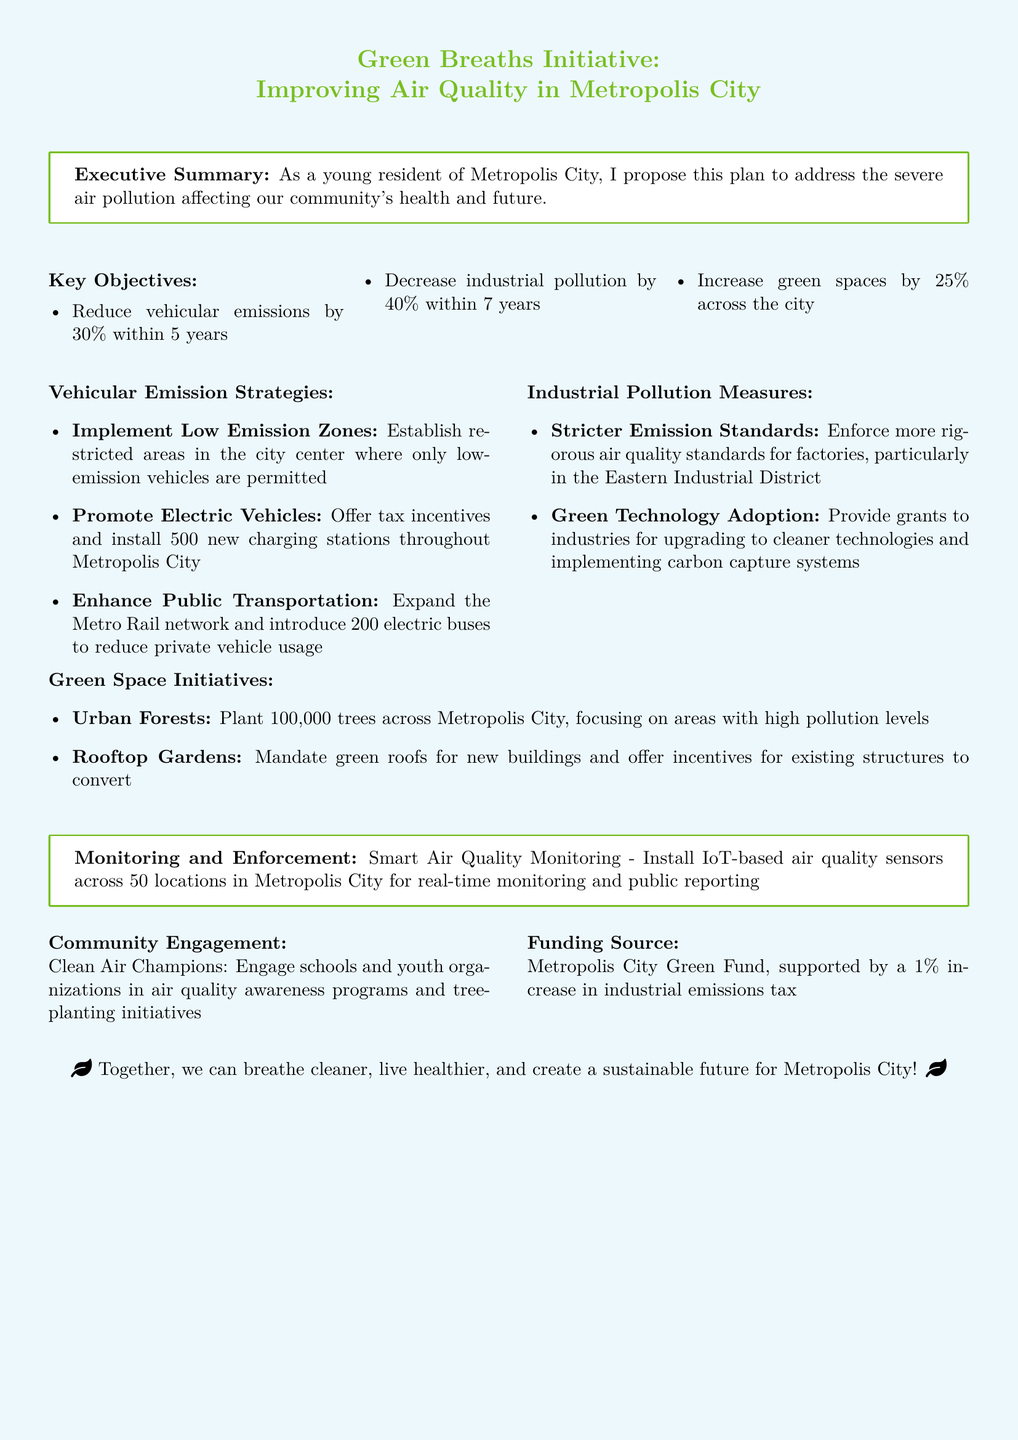what is the target reduction for vehicular emissions? The document states that the objective is to reduce vehicular emissions by 30\% within 5 years.
Answer: 30% what are the key strategies for reducing vehicular emissions? The strategies include implementing Low Emission Zones, promoting Electric Vehicles, and enhancing Public Transportation.
Answer: Low Emission Zones, Electric Vehicles, Public Transportation how many charging stations will be installed for electric vehicles? The plan mentions that 500 new charging stations will be installed throughout Metropolis City.
Answer: 500 what is the goal for decreasing industrial pollution? The objective outlined is to decrease industrial pollution by 40\% within 7 years.
Answer: 40% which district will face stricter emission standards? Stricter emission standards will be enforced particularly in the Eastern Industrial District.
Answer: Eastern Industrial District how many trees will be planted across Metropolis City? The initiative aims to plant 100,000 trees across the city.
Answer: 100,000 what is the funding source for the Green Breaths Initiative? The funding will come from the Metropolis City Green Fund, supported by a 1\% increase in industrial emissions tax.
Answer: Metropolis City Green Fund what technology will be used for air quality monitoring? The document mentions that IoT-based air quality sensors will be installed for real-time monitoring.
Answer: IoT-based air quality sensors how will community engagement be promoted? The document proposes engaging schools and youth organizations in air quality awareness programs and tree-planting initiatives.
Answer: Clean Air Champions what is the incentive for existing buildings to implement green roofs? The document states that there will be incentives for existing structures to convert to green roofs.
Answer: Incentives for existing structures 